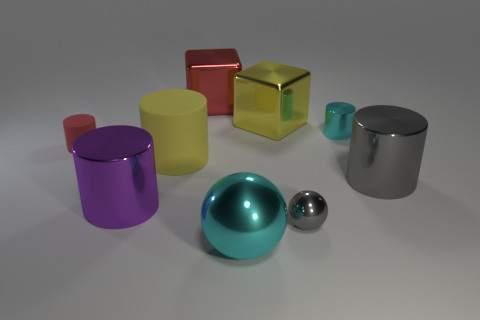Subtract 1 cylinders. How many cylinders are left? 4 Subtract all gray cylinders. How many cylinders are left? 4 Subtract all gray metal cylinders. How many cylinders are left? 4 Subtract all yellow cubes. Subtract all cyan cylinders. How many cubes are left? 1 Add 1 small cylinders. How many objects exist? 10 Subtract all balls. How many objects are left? 7 Add 6 green metallic cylinders. How many green metallic cylinders exist? 6 Subtract 1 purple cylinders. How many objects are left? 8 Subtract all cyan cylinders. Subtract all large gray metal cylinders. How many objects are left? 7 Add 9 cyan metallic cylinders. How many cyan metallic cylinders are left? 10 